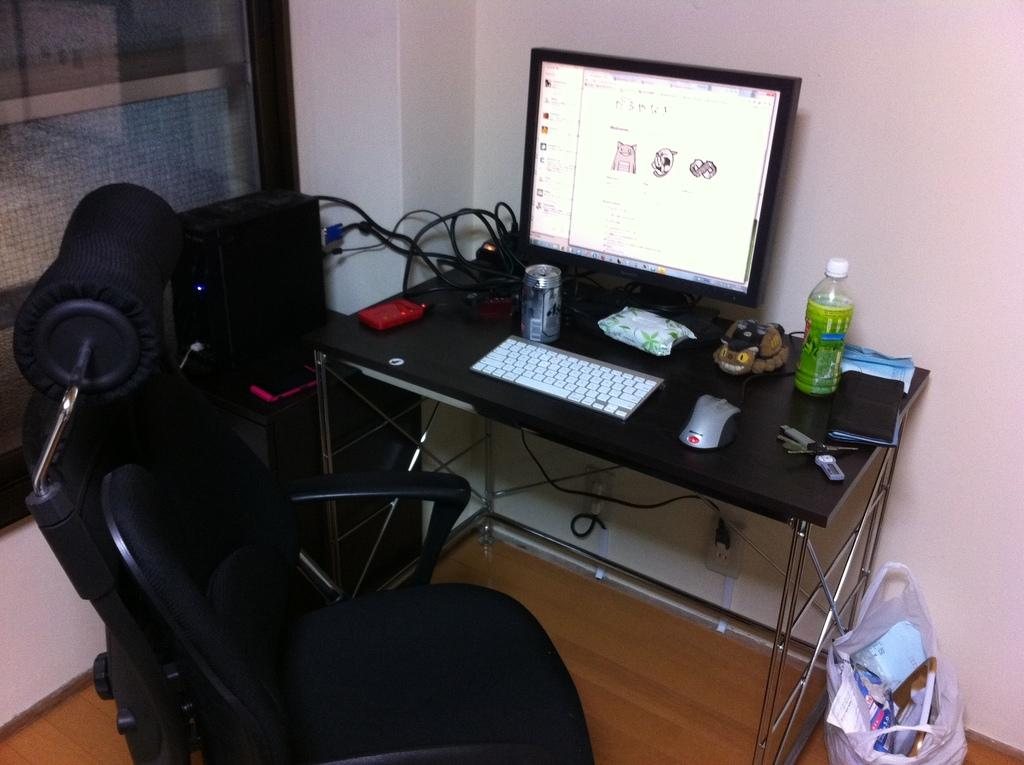What type of electronic device is visible in the image? There is a monitor in the image. What is used for input with the monitor? There is a keyboard and a mouse in the image. What type of beverages can be seen in the image? There is a can and a bottle in the image. How are the objects arranged in the image? The objects are on a table, and there is a chair and a cover present as well. What is the background of the image? There is a wall in the image. How many pies are on the table in the image? There are no pies present in the image. What type of watch is visible on the wall in the image? There is no watch visible in the image; only a monitor, keyboard, mouse, can, bottle, wires, table, chair, cover, and wall are present. 